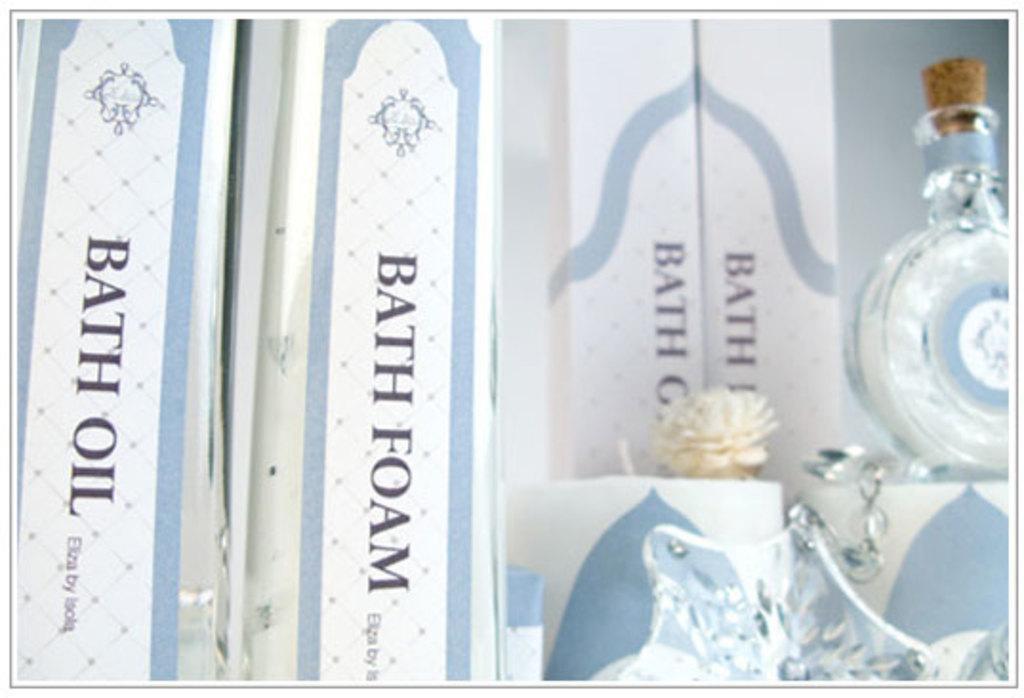Describe this image in one or two sentences. On the right side of the image there is a bottle. At the bottom of the image there is a crystal object. And in the image there are few boxes with names on it. 